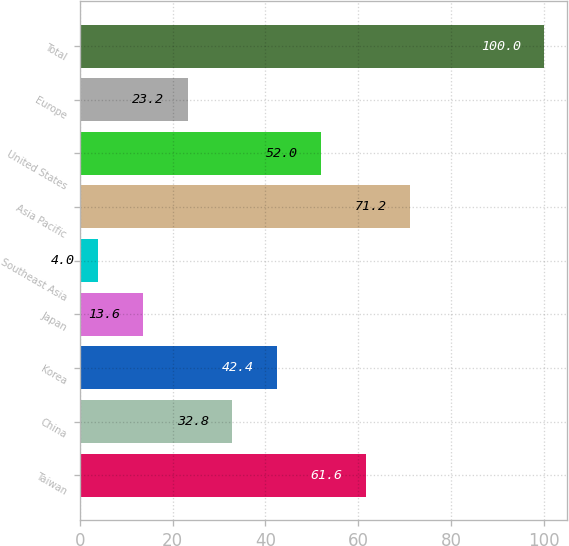Convert chart to OTSL. <chart><loc_0><loc_0><loc_500><loc_500><bar_chart><fcel>Taiwan<fcel>China<fcel>Korea<fcel>Japan<fcel>Southeast Asia<fcel>Asia Pacific<fcel>United States<fcel>Europe<fcel>Total<nl><fcel>61.6<fcel>32.8<fcel>42.4<fcel>13.6<fcel>4<fcel>71.2<fcel>52<fcel>23.2<fcel>100<nl></chart> 